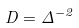Convert formula to latex. <formula><loc_0><loc_0><loc_500><loc_500>D = \Delta ^ { - 2 }</formula> 